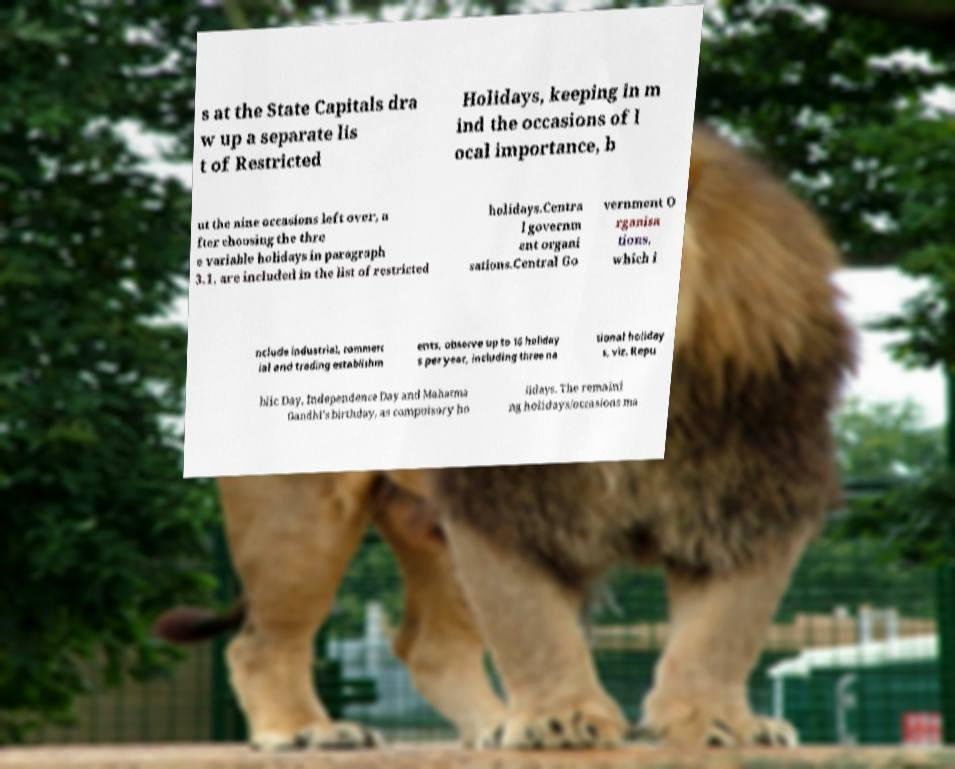Could you assist in decoding the text presented in this image and type it out clearly? s at the State Capitals dra w up a separate lis t of Restricted Holidays, keeping in m ind the occasions of l ocal importance, b ut the nine occasions left over, a fter choosing the thre e variable holidays in paragraph 3.1, are included in the list of restricted holidays.Centra l governm ent organi sations.Central Go vernment O rganisa tions, which i nclude industrial, commerc ial and trading establishm ents, observe up to 16 holiday s per year, including three na tional holiday s, viz. Repu blic Day, Independence Day and Mahatma Gandhi's birthday, as compulsory ho lidays. The remaini ng holidays/occasions ma 